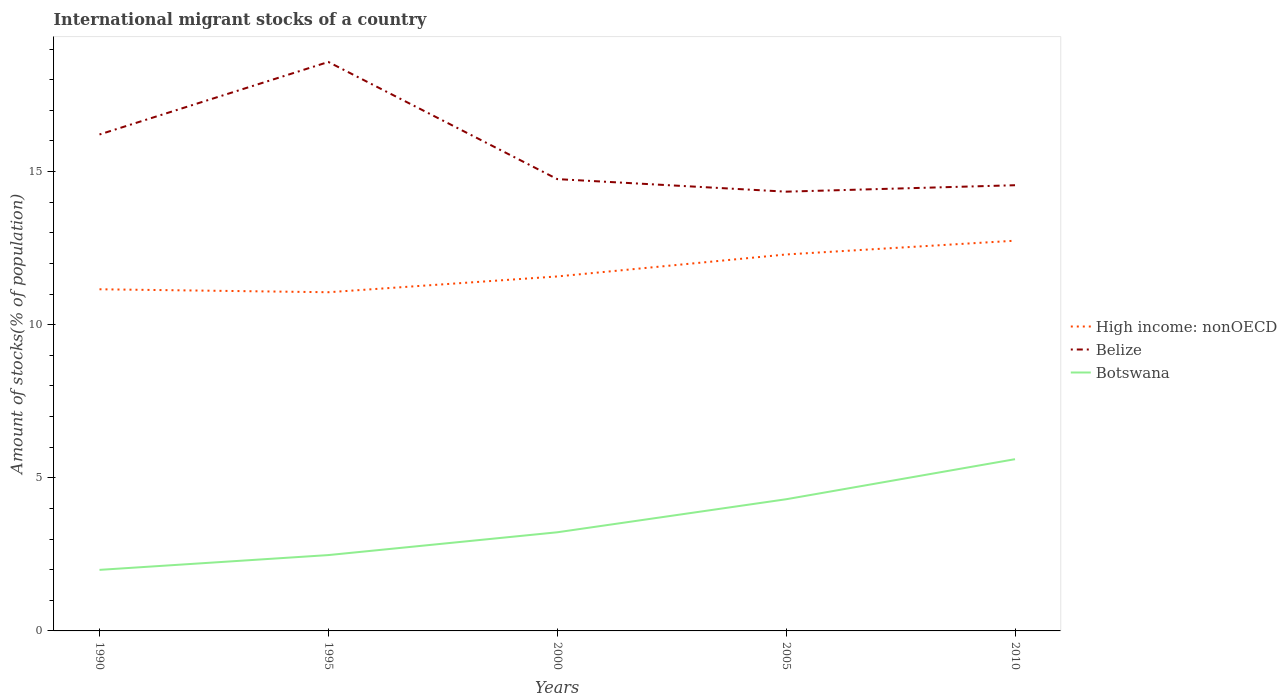How many different coloured lines are there?
Provide a short and direct response. 3. Does the line corresponding to High income: nonOECD intersect with the line corresponding to Belize?
Provide a short and direct response. No. Across all years, what is the maximum amount of stocks in in High income: nonOECD?
Offer a terse response. 11.06. What is the total amount of stocks in in Belize in the graph?
Offer a terse response. 0.41. What is the difference between the highest and the second highest amount of stocks in in Belize?
Your response must be concise. 4.23. How many lines are there?
Provide a short and direct response. 3. How many years are there in the graph?
Give a very brief answer. 5. What is the difference between two consecutive major ticks on the Y-axis?
Your answer should be very brief. 5. Are the values on the major ticks of Y-axis written in scientific E-notation?
Keep it short and to the point. No. Does the graph contain any zero values?
Offer a very short reply. No. Does the graph contain grids?
Offer a terse response. No. How are the legend labels stacked?
Give a very brief answer. Vertical. What is the title of the graph?
Provide a succinct answer. International migrant stocks of a country. Does "Uzbekistan" appear as one of the legend labels in the graph?
Keep it short and to the point. No. What is the label or title of the X-axis?
Give a very brief answer. Years. What is the label or title of the Y-axis?
Ensure brevity in your answer.  Amount of stocks(% of population). What is the Amount of stocks(% of population) of High income: nonOECD in 1990?
Give a very brief answer. 11.16. What is the Amount of stocks(% of population) in Belize in 1990?
Offer a terse response. 16.21. What is the Amount of stocks(% of population) of Botswana in 1990?
Your response must be concise. 1.99. What is the Amount of stocks(% of population) of High income: nonOECD in 1995?
Keep it short and to the point. 11.06. What is the Amount of stocks(% of population) in Belize in 1995?
Give a very brief answer. 18.58. What is the Amount of stocks(% of population) in Botswana in 1995?
Offer a very short reply. 2.48. What is the Amount of stocks(% of population) in High income: nonOECD in 2000?
Keep it short and to the point. 11.58. What is the Amount of stocks(% of population) in Belize in 2000?
Give a very brief answer. 14.75. What is the Amount of stocks(% of population) in Botswana in 2000?
Keep it short and to the point. 3.22. What is the Amount of stocks(% of population) of High income: nonOECD in 2005?
Give a very brief answer. 12.29. What is the Amount of stocks(% of population) of Belize in 2005?
Make the answer very short. 14.34. What is the Amount of stocks(% of population) of Botswana in 2005?
Offer a terse response. 4.3. What is the Amount of stocks(% of population) in High income: nonOECD in 2010?
Your answer should be very brief. 12.74. What is the Amount of stocks(% of population) in Belize in 2010?
Make the answer very short. 14.55. What is the Amount of stocks(% of population) of Botswana in 2010?
Keep it short and to the point. 5.61. Across all years, what is the maximum Amount of stocks(% of population) of High income: nonOECD?
Make the answer very short. 12.74. Across all years, what is the maximum Amount of stocks(% of population) of Belize?
Your answer should be compact. 18.58. Across all years, what is the maximum Amount of stocks(% of population) in Botswana?
Your answer should be compact. 5.61. Across all years, what is the minimum Amount of stocks(% of population) of High income: nonOECD?
Keep it short and to the point. 11.06. Across all years, what is the minimum Amount of stocks(% of population) of Belize?
Give a very brief answer. 14.34. Across all years, what is the minimum Amount of stocks(% of population) of Botswana?
Keep it short and to the point. 1.99. What is the total Amount of stocks(% of population) in High income: nonOECD in the graph?
Keep it short and to the point. 58.83. What is the total Amount of stocks(% of population) of Belize in the graph?
Give a very brief answer. 78.44. What is the total Amount of stocks(% of population) of Botswana in the graph?
Your answer should be compact. 17.6. What is the difference between the Amount of stocks(% of population) of High income: nonOECD in 1990 and that in 1995?
Make the answer very short. 0.1. What is the difference between the Amount of stocks(% of population) in Belize in 1990 and that in 1995?
Ensure brevity in your answer.  -2.37. What is the difference between the Amount of stocks(% of population) of Botswana in 1990 and that in 1995?
Provide a short and direct response. -0.48. What is the difference between the Amount of stocks(% of population) in High income: nonOECD in 1990 and that in 2000?
Provide a short and direct response. -0.42. What is the difference between the Amount of stocks(% of population) of Belize in 1990 and that in 2000?
Offer a terse response. 1.46. What is the difference between the Amount of stocks(% of population) in Botswana in 1990 and that in 2000?
Offer a very short reply. -1.23. What is the difference between the Amount of stocks(% of population) of High income: nonOECD in 1990 and that in 2005?
Make the answer very short. -1.14. What is the difference between the Amount of stocks(% of population) of Belize in 1990 and that in 2005?
Provide a short and direct response. 1.87. What is the difference between the Amount of stocks(% of population) of Botswana in 1990 and that in 2005?
Ensure brevity in your answer.  -2.31. What is the difference between the Amount of stocks(% of population) of High income: nonOECD in 1990 and that in 2010?
Offer a very short reply. -1.59. What is the difference between the Amount of stocks(% of population) in Belize in 1990 and that in 2010?
Your response must be concise. 1.66. What is the difference between the Amount of stocks(% of population) in Botswana in 1990 and that in 2010?
Offer a terse response. -3.61. What is the difference between the Amount of stocks(% of population) of High income: nonOECD in 1995 and that in 2000?
Provide a short and direct response. -0.52. What is the difference between the Amount of stocks(% of population) in Belize in 1995 and that in 2000?
Your answer should be compact. 3.82. What is the difference between the Amount of stocks(% of population) of Botswana in 1995 and that in 2000?
Your answer should be very brief. -0.74. What is the difference between the Amount of stocks(% of population) in High income: nonOECD in 1995 and that in 2005?
Your answer should be compact. -1.23. What is the difference between the Amount of stocks(% of population) of Belize in 1995 and that in 2005?
Offer a very short reply. 4.24. What is the difference between the Amount of stocks(% of population) of Botswana in 1995 and that in 2005?
Make the answer very short. -1.82. What is the difference between the Amount of stocks(% of population) of High income: nonOECD in 1995 and that in 2010?
Your answer should be very brief. -1.68. What is the difference between the Amount of stocks(% of population) of Belize in 1995 and that in 2010?
Provide a succinct answer. 4.02. What is the difference between the Amount of stocks(% of population) of Botswana in 1995 and that in 2010?
Keep it short and to the point. -3.13. What is the difference between the Amount of stocks(% of population) of High income: nonOECD in 2000 and that in 2005?
Ensure brevity in your answer.  -0.72. What is the difference between the Amount of stocks(% of population) in Belize in 2000 and that in 2005?
Your answer should be compact. 0.41. What is the difference between the Amount of stocks(% of population) in Botswana in 2000 and that in 2005?
Provide a succinct answer. -1.08. What is the difference between the Amount of stocks(% of population) of High income: nonOECD in 2000 and that in 2010?
Make the answer very short. -1.17. What is the difference between the Amount of stocks(% of population) in Belize in 2000 and that in 2010?
Offer a terse response. 0.2. What is the difference between the Amount of stocks(% of population) in Botswana in 2000 and that in 2010?
Offer a very short reply. -2.39. What is the difference between the Amount of stocks(% of population) in High income: nonOECD in 2005 and that in 2010?
Your answer should be compact. -0.45. What is the difference between the Amount of stocks(% of population) of Belize in 2005 and that in 2010?
Keep it short and to the point. -0.21. What is the difference between the Amount of stocks(% of population) in Botswana in 2005 and that in 2010?
Make the answer very short. -1.31. What is the difference between the Amount of stocks(% of population) of High income: nonOECD in 1990 and the Amount of stocks(% of population) of Belize in 1995?
Ensure brevity in your answer.  -7.42. What is the difference between the Amount of stocks(% of population) in High income: nonOECD in 1990 and the Amount of stocks(% of population) in Botswana in 1995?
Give a very brief answer. 8.68. What is the difference between the Amount of stocks(% of population) in Belize in 1990 and the Amount of stocks(% of population) in Botswana in 1995?
Provide a succinct answer. 13.73. What is the difference between the Amount of stocks(% of population) in High income: nonOECD in 1990 and the Amount of stocks(% of population) in Belize in 2000?
Your answer should be very brief. -3.6. What is the difference between the Amount of stocks(% of population) in High income: nonOECD in 1990 and the Amount of stocks(% of population) in Botswana in 2000?
Give a very brief answer. 7.94. What is the difference between the Amount of stocks(% of population) of Belize in 1990 and the Amount of stocks(% of population) of Botswana in 2000?
Your answer should be compact. 12.99. What is the difference between the Amount of stocks(% of population) of High income: nonOECD in 1990 and the Amount of stocks(% of population) of Belize in 2005?
Offer a very short reply. -3.19. What is the difference between the Amount of stocks(% of population) of High income: nonOECD in 1990 and the Amount of stocks(% of population) of Botswana in 2005?
Make the answer very short. 6.86. What is the difference between the Amount of stocks(% of population) in Belize in 1990 and the Amount of stocks(% of population) in Botswana in 2005?
Provide a succinct answer. 11.91. What is the difference between the Amount of stocks(% of population) of High income: nonOECD in 1990 and the Amount of stocks(% of population) of Belize in 2010?
Your answer should be compact. -3.4. What is the difference between the Amount of stocks(% of population) in High income: nonOECD in 1990 and the Amount of stocks(% of population) in Botswana in 2010?
Keep it short and to the point. 5.55. What is the difference between the Amount of stocks(% of population) of Belize in 1990 and the Amount of stocks(% of population) of Botswana in 2010?
Offer a very short reply. 10.6. What is the difference between the Amount of stocks(% of population) of High income: nonOECD in 1995 and the Amount of stocks(% of population) of Belize in 2000?
Provide a succinct answer. -3.69. What is the difference between the Amount of stocks(% of population) of High income: nonOECD in 1995 and the Amount of stocks(% of population) of Botswana in 2000?
Ensure brevity in your answer.  7.84. What is the difference between the Amount of stocks(% of population) in Belize in 1995 and the Amount of stocks(% of population) in Botswana in 2000?
Provide a short and direct response. 15.36. What is the difference between the Amount of stocks(% of population) of High income: nonOECD in 1995 and the Amount of stocks(% of population) of Belize in 2005?
Your answer should be compact. -3.28. What is the difference between the Amount of stocks(% of population) in High income: nonOECD in 1995 and the Amount of stocks(% of population) in Botswana in 2005?
Your answer should be compact. 6.76. What is the difference between the Amount of stocks(% of population) in Belize in 1995 and the Amount of stocks(% of population) in Botswana in 2005?
Give a very brief answer. 14.28. What is the difference between the Amount of stocks(% of population) in High income: nonOECD in 1995 and the Amount of stocks(% of population) in Belize in 2010?
Provide a short and direct response. -3.49. What is the difference between the Amount of stocks(% of population) of High income: nonOECD in 1995 and the Amount of stocks(% of population) of Botswana in 2010?
Ensure brevity in your answer.  5.45. What is the difference between the Amount of stocks(% of population) in Belize in 1995 and the Amount of stocks(% of population) in Botswana in 2010?
Provide a succinct answer. 12.97. What is the difference between the Amount of stocks(% of population) in High income: nonOECD in 2000 and the Amount of stocks(% of population) in Belize in 2005?
Keep it short and to the point. -2.77. What is the difference between the Amount of stocks(% of population) in High income: nonOECD in 2000 and the Amount of stocks(% of population) in Botswana in 2005?
Make the answer very short. 7.28. What is the difference between the Amount of stocks(% of population) of Belize in 2000 and the Amount of stocks(% of population) of Botswana in 2005?
Provide a succinct answer. 10.45. What is the difference between the Amount of stocks(% of population) in High income: nonOECD in 2000 and the Amount of stocks(% of population) in Belize in 2010?
Provide a succinct answer. -2.98. What is the difference between the Amount of stocks(% of population) of High income: nonOECD in 2000 and the Amount of stocks(% of population) of Botswana in 2010?
Offer a very short reply. 5.97. What is the difference between the Amount of stocks(% of population) in Belize in 2000 and the Amount of stocks(% of population) in Botswana in 2010?
Offer a terse response. 9.15. What is the difference between the Amount of stocks(% of population) of High income: nonOECD in 2005 and the Amount of stocks(% of population) of Belize in 2010?
Provide a short and direct response. -2.26. What is the difference between the Amount of stocks(% of population) of High income: nonOECD in 2005 and the Amount of stocks(% of population) of Botswana in 2010?
Offer a terse response. 6.69. What is the difference between the Amount of stocks(% of population) in Belize in 2005 and the Amount of stocks(% of population) in Botswana in 2010?
Ensure brevity in your answer.  8.74. What is the average Amount of stocks(% of population) in High income: nonOECD per year?
Offer a terse response. 11.77. What is the average Amount of stocks(% of population) of Belize per year?
Give a very brief answer. 15.69. What is the average Amount of stocks(% of population) of Botswana per year?
Ensure brevity in your answer.  3.52. In the year 1990, what is the difference between the Amount of stocks(% of population) of High income: nonOECD and Amount of stocks(% of population) of Belize?
Offer a terse response. -5.05. In the year 1990, what is the difference between the Amount of stocks(% of population) in High income: nonOECD and Amount of stocks(% of population) in Botswana?
Provide a short and direct response. 9.16. In the year 1990, what is the difference between the Amount of stocks(% of population) in Belize and Amount of stocks(% of population) in Botswana?
Offer a very short reply. 14.22. In the year 1995, what is the difference between the Amount of stocks(% of population) of High income: nonOECD and Amount of stocks(% of population) of Belize?
Your answer should be very brief. -7.52. In the year 1995, what is the difference between the Amount of stocks(% of population) in High income: nonOECD and Amount of stocks(% of population) in Botswana?
Ensure brevity in your answer.  8.58. In the year 1995, what is the difference between the Amount of stocks(% of population) of Belize and Amount of stocks(% of population) of Botswana?
Keep it short and to the point. 16.1. In the year 2000, what is the difference between the Amount of stocks(% of population) in High income: nonOECD and Amount of stocks(% of population) in Belize?
Provide a succinct answer. -3.18. In the year 2000, what is the difference between the Amount of stocks(% of population) of High income: nonOECD and Amount of stocks(% of population) of Botswana?
Keep it short and to the point. 8.35. In the year 2000, what is the difference between the Amount of stocks(% of population) in Belize and Amount of stocks(% of population) in Botswana?
Keep it short and to the point. 11.53. In the year 2005, what is the difference between the Amount of stocks(% of population) of High income: nonOECD and Amount of stocks(% of population) of Belize?
Provide a succinct answer. -2.05. In the year 2005, what is the difference between the Amount of stocks(% of population) in High income: nonOECD and Amount of stocks(% of population) in Botswana?
Ensure brevity in your answer.  7.99. In the year 2005, what is the difference between the Amount of stocks(% of population) of Belize and Amount of stocks(% of population) of Botswana?
Provide a short and direct response. 10.04. In the year 2010, what is the difference between the Amount of stocks(% of population) in High income: nonOECD and Amount of stocks(% of population) in Belize?
Your answer should be very brief. -1.81. In the year 2010, what is the difference between the Amount of stocks(% of population) in High income: nonOECD and Amount of stocks(% of population) in Botswana?
Give a very brief answer. 7.13. In the year 2010, what is the difference between the Amount of stocks(% of population) in Belize and Amount of stocks(% of population) in Botswana?
Provide a succinct answer. 8.95. What is the ratio of the Amount of stocks(% of population) of High income: nonOECD in 1990 to that in 1995?
Ensure brevity in your answer.  1.01. What is the ratio of the Amount of stocks(% of population) in Belize in 1990 to that in 1995?
Provide a succinct answer. 0.87. What is the ratio of the Amount of stocks(% of population) of Botswana in 1990 to that in 1995?
Provide a short and direct response. 0.81. What is the ratio of the Amount of stocks(% of population) in High income: nonOECD in 1990 to that in 2000?
Offer a terse response. 0.96. What is the ratio of the Amount of stocks(% of population) of Belize in 1990 to that in 2000?
Offer a terse response. 1.1. What is the ratio of the Amount of stocks(% of population) of Botswana in 1990 to that in 2000?
Your response must be concise. 0.62. What is the ratio of the Amount of stocks(% of population) in High income: nonOECD in 1990 to that in 2005?
Your answer should be compact. 0.91. What is the ratio of the Amount of stocks(% of population) in Belize in 1990 to that in 2005?
Keep it short and to the point. 1.13. What is the ratio of the Amount of stocks(% of population) in Botswana in 1990 to that in 2005?
Offer a terse response. 0.46. What is the ratio of the Amount of stocks(% of population) in High income: nonOECD in 1990 to that in 2010?
Ensure brevity in your answer.  0.88. What is the ratio of the Amount of stocks(% of population) of Belize in 1990 to that in 2010?
Provide a succinct answer. 1.11. What is the ratio of the Amount of stocks(% of population) in Botswana in 1990 to that in 2010?
Provide a succinct answer. 0.36. What is the ratio of the Amount of stocks(% of population) in High income: nonOECD in 1995 to that in 2000?
Make the answer very short. 0.96. What is the ratio of the Amount of stocks(% of population) of Belize in 1995 to that in 2000?
Your response must be concise. 1.26. What is the ratio of the Amount of stocks(% of population) of Botswana in 1995 to that in 2000?
Offer a terse response. 0.77. What is the ratio of the Amount of stocks(% of population) of High income: nonOECD in 1995 to that in 2005?
Offer a terse response. 0.9. What is the ratio of the Amount of stocks(% of population) of Belize in 1995 to that in 2005?
Offer a very short reply. 1.3. What is the ratio of the Amount of stocks(% of population) of Botswana in 1995 to that in 2005?
Provide a short and direct response. 0.58. What is the ratio of the Amount of stocks(% of population) in High income: nonOECD in 1995 to that in 2010?
Provide a short and direct response. 0.87. What is the ratio of the Amount of stocks(% of population) of Belize in 1995 to that in 2010?
Provide a succinct answer. 1.28. What is the ratio of the Amount of stocks(% of population) in Botswana in 1995 to that in 2010?
Offer a terse response. 0.44. What is the ratio of the Amount of stocks(% of population) in High income: nonOECD in 2000 to that in 2005?
Offer a very short reply. 0.94. What is the ratio of the Amount of stocks(% of population) in Belize in 2000 to that in 2005?
Make the answer very short. 1.03. What is the ratio of the Amount of stocks(% of population) in Botswana in 2000 to that in 2005?
Provide a short and direct response. 0.75. What is the ratio of the Amount of stocks(% of population) in High income: nonOECD in 2000 to that in 2010?
Make the answer very short. 0.91. What is the ratio of the Amount of stocks(% of population) of Belize in 2000 to that in 2010?
Offer a terse response. 1.01. What is the ratio of the Amount of stocks(% of population) in Botswana in 2000 to that in 2010?
Provide a succinct answer. 0.57. What is the ratio of the Amount of stocks(% of population) in High income: nonOECD in 2005 to that in 2010?
Offer a very short reply. 0.96. What is the ratio of the Amount of stocks(% of population) in Belize in 2005 to that in 2010?
Your answer should be compact. 0.99. What is the ratio of the Amount of stocks(% of population) of Botswana in 2005 to that in 2010?
Your answer should be compact. 0.77. What is the difference between the highest and the second highest Amount of stocks(% of population) of High income: nonOECD?
Give a very brief answer. 0.45. What is the difference between the highest and the second highest Amount of stocks(% of population) in Belize?
Offer a terse response. 2.37. What is the difference between the highest and the second highest Amount of stocks(% of population) in Botswana?
Provide a short and direct response. 1.31. What is the difference between the highest and the lowest Amount of stocks(% of population) of High income: nonOECD?
Provide a short and direct response. 1.68. What is the difference between the highest and the lowest Amount of stocks(% of population) of Belize?
Provide a short and direct response. 4.24. What is the difference between the highest and the lowest Amount of stocks(% of population) of Botswana?
Keep it short and to the point. 3.61. 